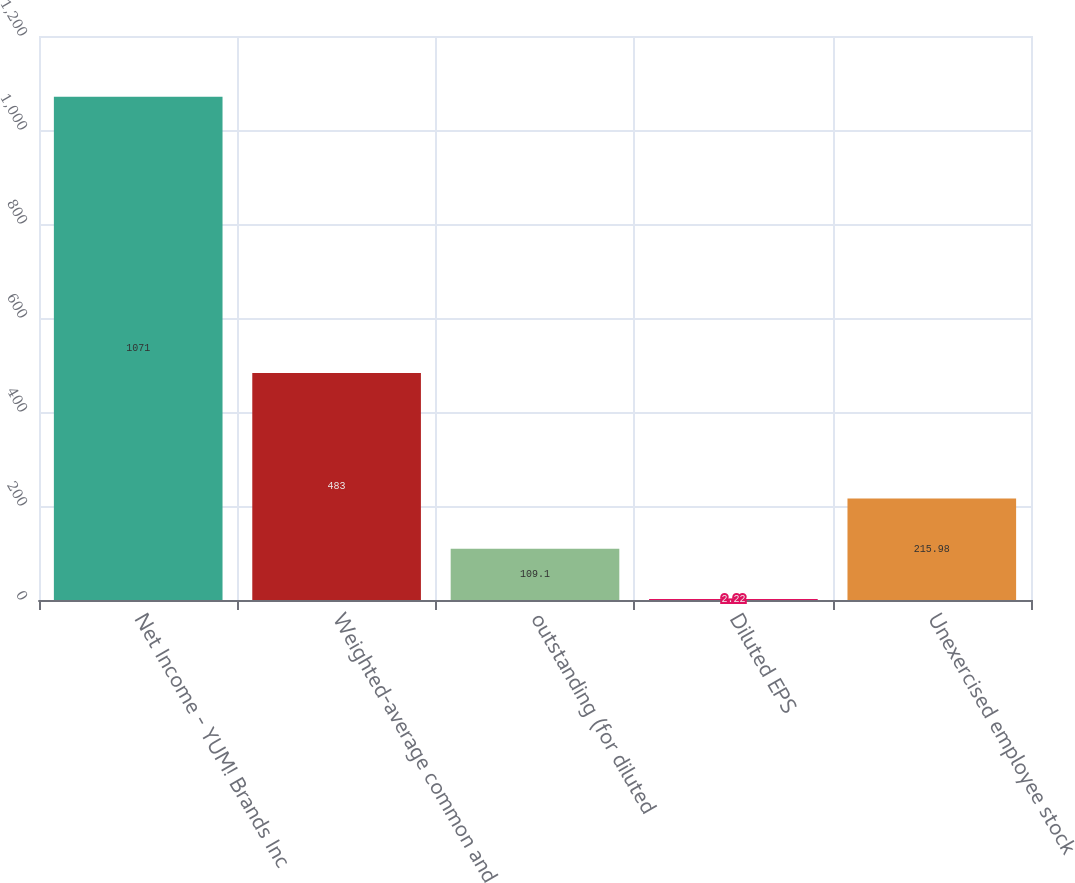Convert chart to OTSL. <chart><loc_0><loc_0><loc_500><loc_500><bar_chart><fcel>Net Income - YUM! Brands Inc<fcel>Weighted-average common and<fcel>outstanding (for diluted<fcel>Diluted EPS<fcel>Unexercised employee stock<nl><fcel>1071<fcel>483<fcel>109.1<fcel>2.22<fcel>215.98<nl></chart> 